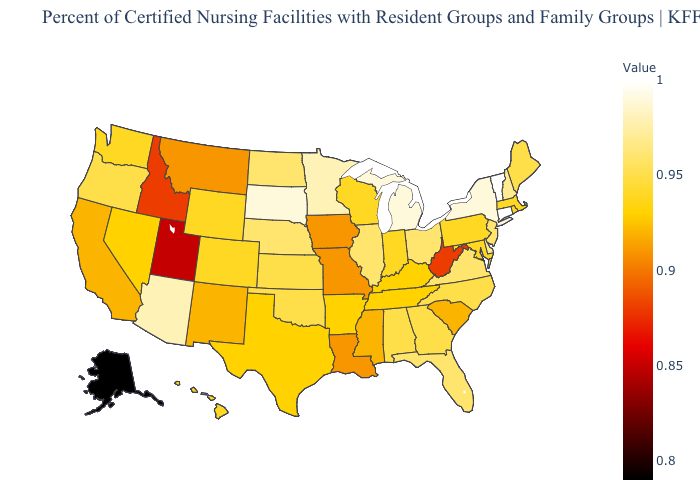Does Iowa have a lower value than Ohio?
Give a very brief answer. Yes. Does Tennessee have a lower value than Florida?
Answer briefly. Yes. Which states have the lowest value in the USA?
Quick response, please. Alaska. 